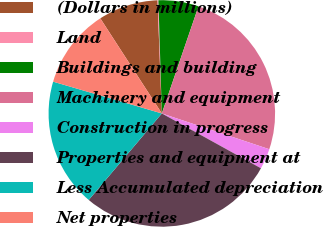<chart> <loc_0><loc_0><loc_500><loc_500><pie_chart><fcel>(Dollars in millions)<fcel>Land<fcel>Buildings and building<fcel>Machinery and equipment<fcel>Construction in progress<fcel>Properties and equipment at<fcel>Less Accumulated depreciation<fcel>Net properties<nl><fcel>8.53%<fcel>0.13%<fcel>5.73%<fcel>24.86%<fcel>2.93%<fcel>28.12%<fcel>18.36%<fcel>11.33%<nl></chart> 